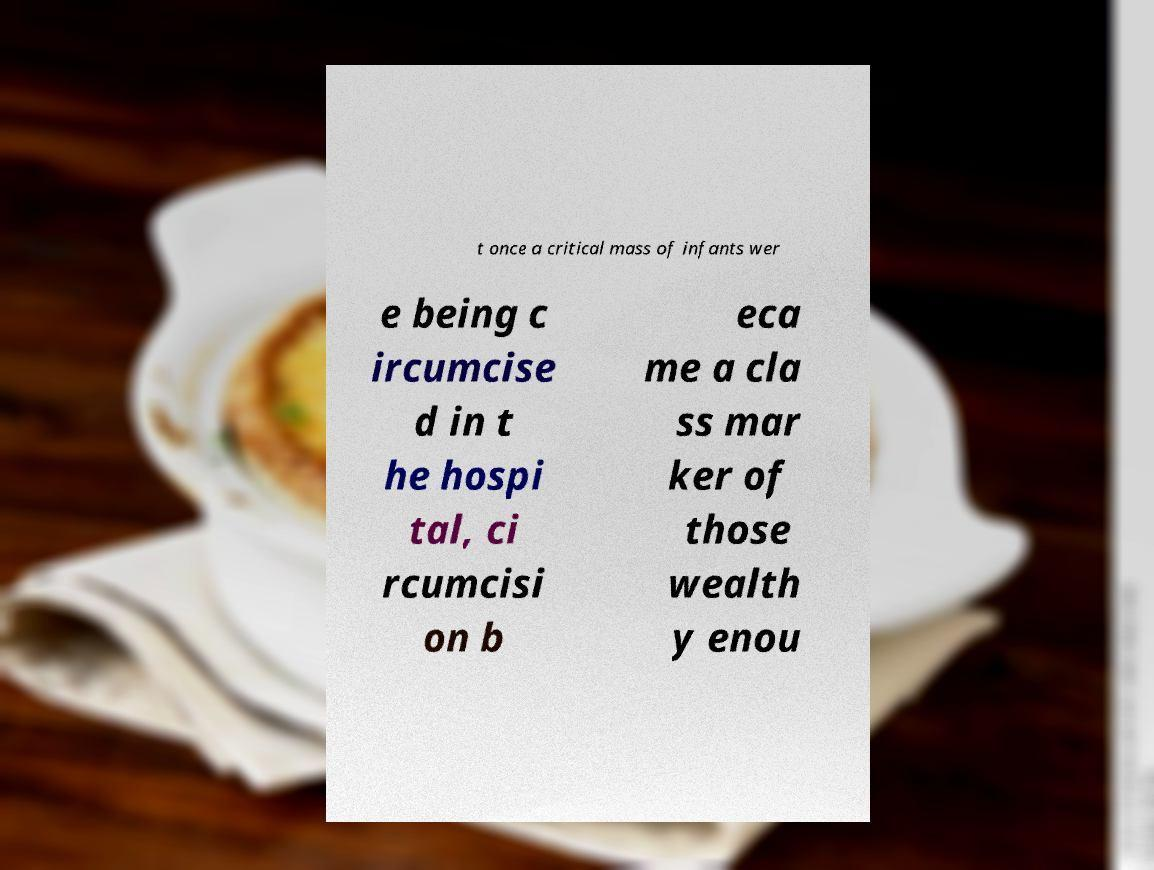Please read and relay the text visible in this image. What does it say? t once a critical mass of infants wer e being c ircumcise d in t he hospi tal, ci rcumcisi on b eca me a cla ss mar ker of those wealth y enou 